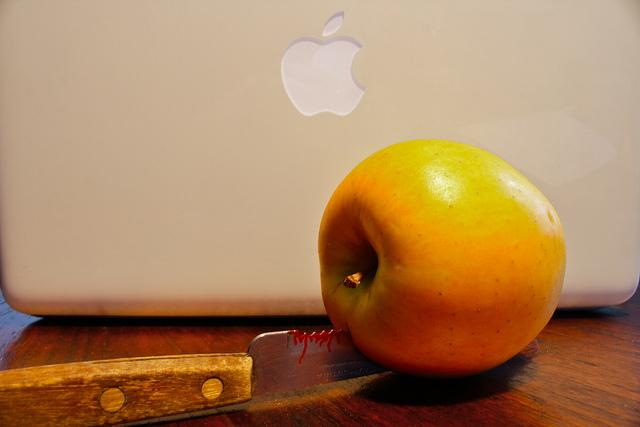What is likely the red substance on the knife? Please explain your reasoning. paint. The substance is paint. 